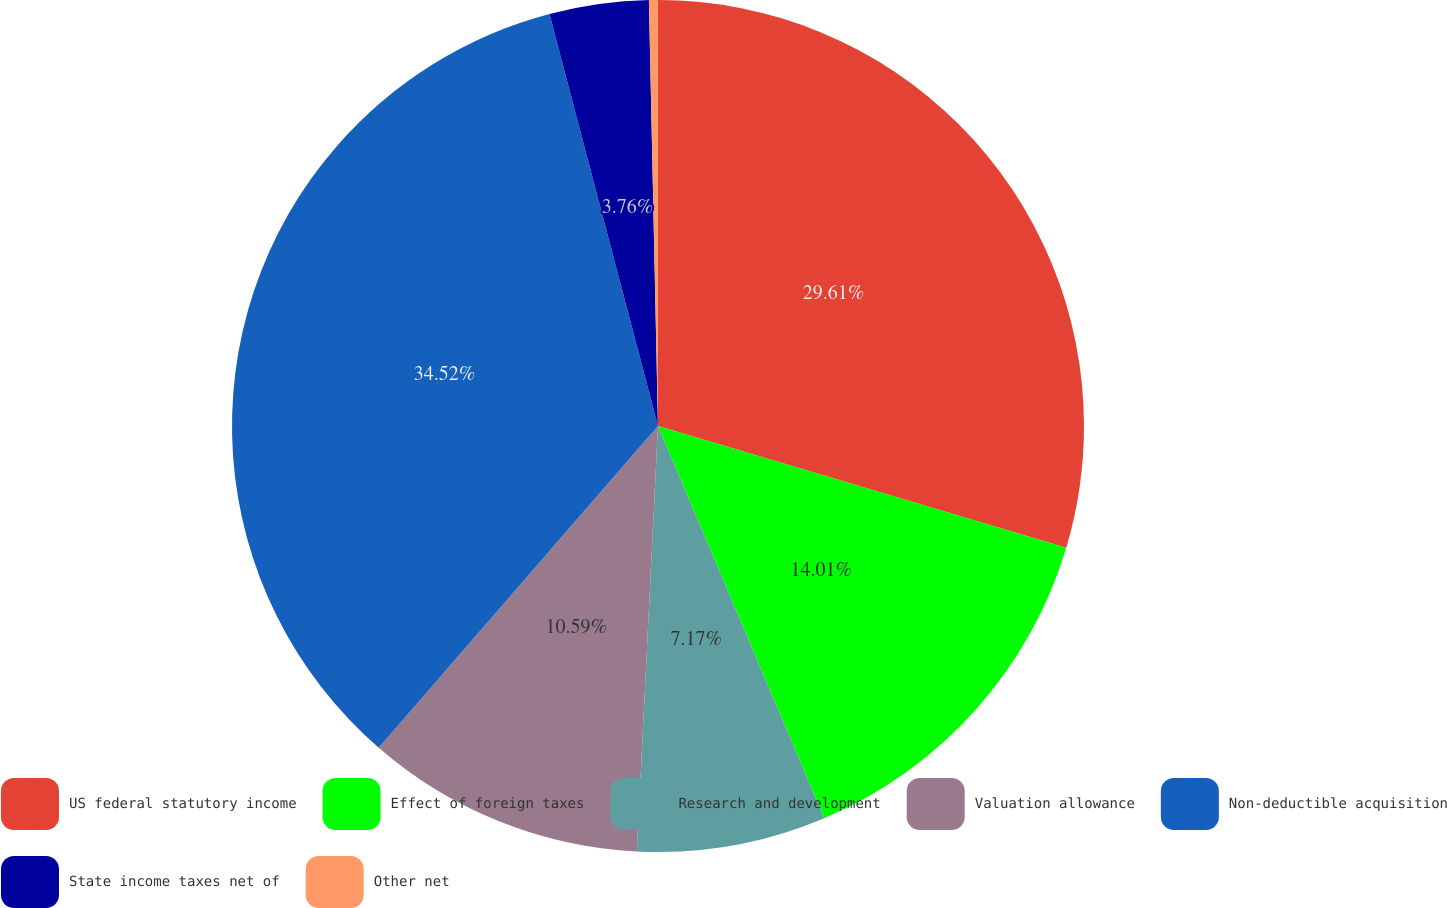Convert chart to OTSL. <chart><loc_0><loc_0><loc_500><loc_500><pie_chart><fcel>US federal statutory income<fcel>Effect of foreign taxes<fcel>Research and development<fcel>Valuation allowance<fcel>Non-deductible acquisition<fcel>State income taxes net of<fcel>Other net<nl><fcel>29.61%<fcel>14.01%<fcel>7.17%<fcel>10.59%<fcel>34.52%<fcel>3.76%<fcel>0.34%<nl></chart> 